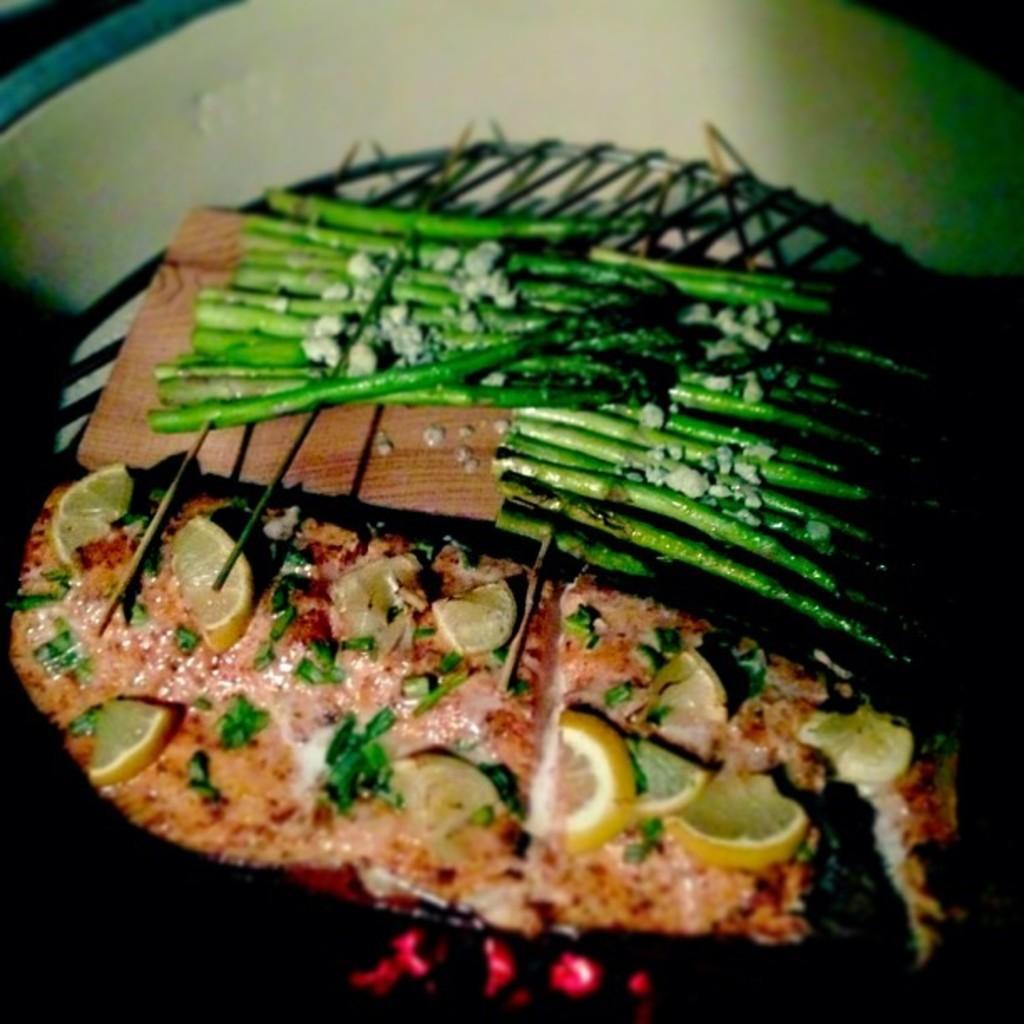In one or two sentences, can you explain what this image depicts? In this image I can see the board with food items on it. The board is on the grill. I can see the girl is on the white color surface. 